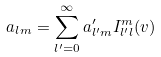<formula> <loc_0><loc_0><loc_500><loc_500>a _ { l m } = \sum _ { l ^ { \prime } = 0 } ^ { \infty } a ^ { \prime } _ { l ^ { \prime } m } I ^ { m } _ { l ^ { \prime } l } ( v )</formula> 